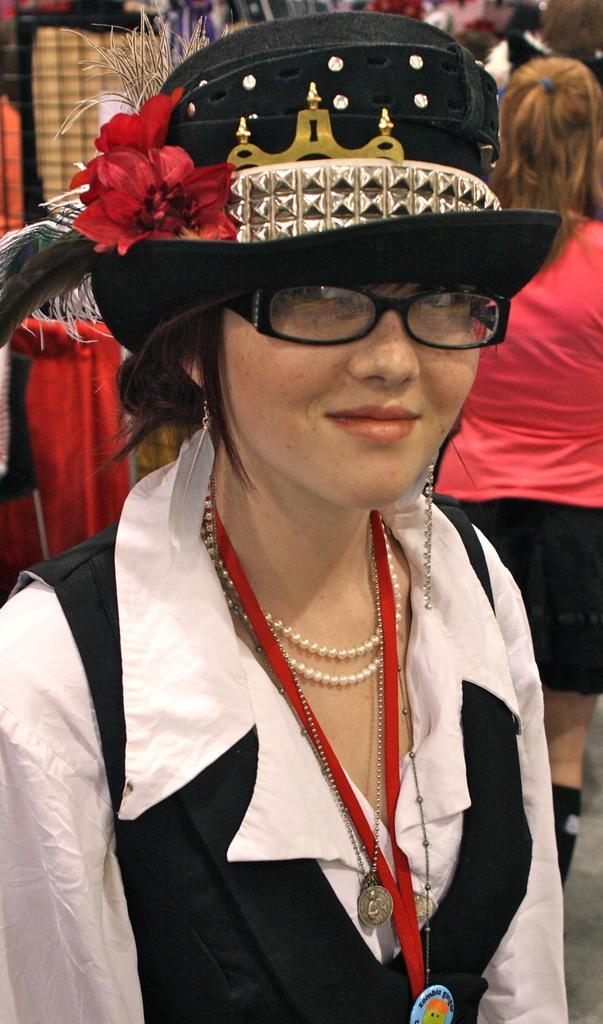How would you summarize this image in a sentence or two? In the center of the image we can see a woman wearing a black hat and smiling. In the background we can see another woman. We can also see the clothes. 